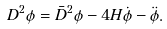Convert formula to latex. <formula><loc_0><loc_0><loc_500><loc_500>D ^ { 2 } \phi = \bar { D } ^ { 2 } \phi - 4 H \dot { \phi } - \ddot { \phi } .</formula> 